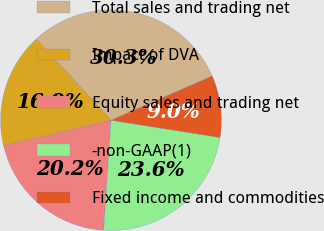Convert chart. <chart><loc_0><loc_0><loc_500><loc_500><pie_chart><fcel>Total sales and trading net<fcel>Impact of DVA<fcel>Equity sales and trading net<fcel>-non-GAAP(1)<fcel>Fixed income and commodities<nl><fcel>30.26%<fcel>16.89%<fcel>20.23%<fcel>23.57%<fcel>9.05%<nl></chart> 